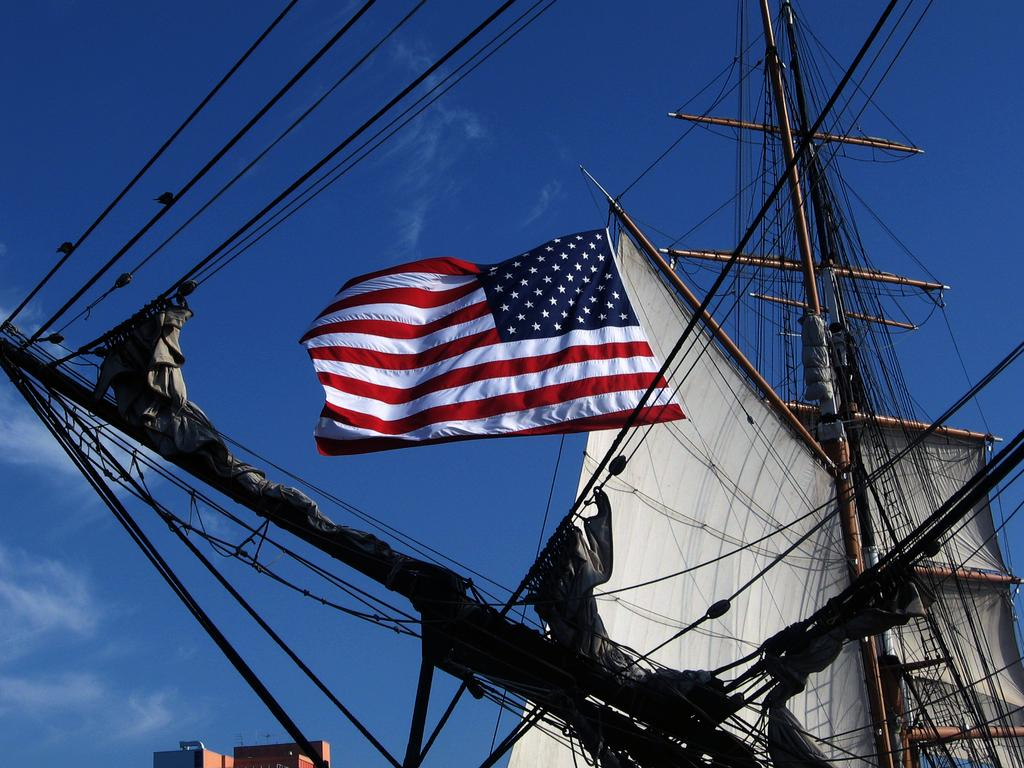What is the main subject of the picture? The main subject of the picture is a boat. What else can be seen in the picture besides the boat? There is a flag and a building at the bottom of the picture. How would you describe the sky in the picture? The sky is blue and cloudy in the picture. Where is the writer sitting in the picture? There is no writer present in the picture. How many parcels are visible in the picture? There are no parcels visible in the picture. 